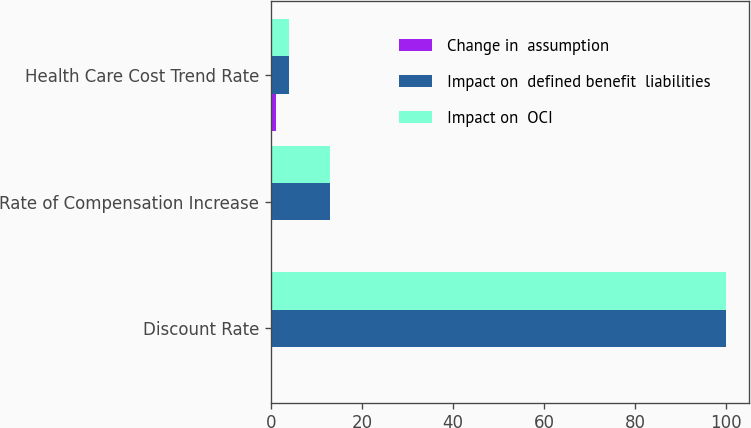Convert chart to OTSL. <chart><loc_0><loc_0><loc_500><loc_500><stacked_bar_chart><ecel><fcel>Discount Rate<fcel>Rate of Compensation Increase<fcel>Health Care Cost Trend Rate<nl><fcel>Change in  assumption<fcel>0.25<fcel>0.25<fcel>1<nl><fcel>Impact on  defined benefit  liabilities<fcel>100<fcel>13<fcel>4<nl><fcel>Impact on  OCI<fcel>100<fcel>13<fcel>4<nl></chart> 